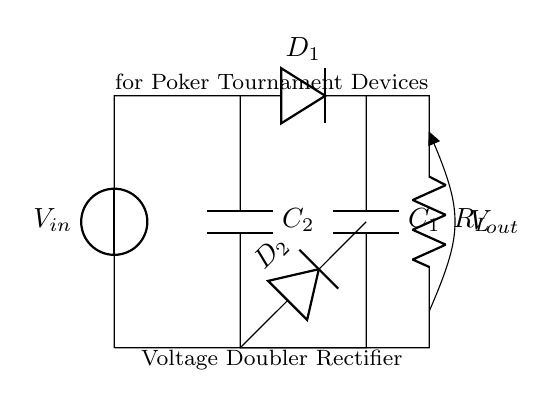What is the purpose of the circuit? The purpose of the circuit is to function as a voltage doubler rectifier, which is designed to provide a higher voltage output by doubling the input voltage. This is indicated in the diagram by its label and the inclusion of specific components for this function.
Answer: Voltage doubler rectifier How many diodes are present in the circuit? There are two diodes in the circuit, labeled as D1 and D2. This can be confirmed by counting the diode symbols in the diagram, which represent the direction of current flow in a rectifying configuration.
Answer: Two What is the total capacitance of the capacitors? The total capacitance is not explicitly stated in the diagram; however, with two capacitors present (C1 and C2), and their individual values typically available in a complete design document, one would generally sum their values for total capacitance if connected in the correct configuration. Since the values are not provided, we cannot determine a specific total.
Answer: Not determinable What is the role of the load resistor R_L? The load resistor R_L is used to represent the device being powered by the rectifier output. It is essential for determining the amount of current that will be drawn from the circuit, thereby influencing the overall performance and efficiency of the rectifier.
Answer: Load representation What type of rectification does this circuit involve? The circuit involves full-wave rectification, as indicated by two diodes that allow current to flow during both halves of the AC cycle. This can be seen from the arrangement of the components that enables both positive and negative cycles to contribute to the output voltage effectively.
Answer: Full-wave Where is the output voltage measured in the circuit? The output voltage is measured across the load resistor R_L, where it is marked as V_out. This point indicates the voltage available to be supplied to the connected device, reflecting the performance of the voltage doubler circuit.
Answer: Across R_L How is the voltage output affected by the capacitors? The voltage output is affected by the capacitors C1 and C2, as they store charge during the AC input cycles and release it to maintain higher voltage levels at the output. The interaction of the capacitors in a voltage doubler configuration significantly smooths the output and minimizes ripple voltage.
Answer: Stabilizes output 